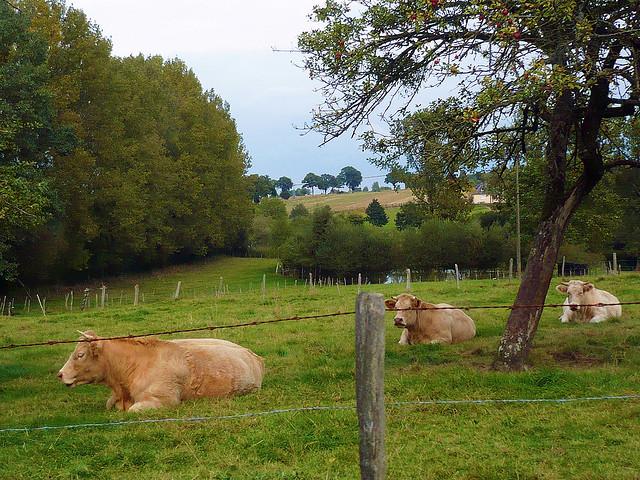What are the cows laying on?
Short answer required. Grass. What is the  name of the farmer of song-tradition that has one of these?
Be succinct. Old macdonald. How many cows are standing?
Write a very short answer. 0. 